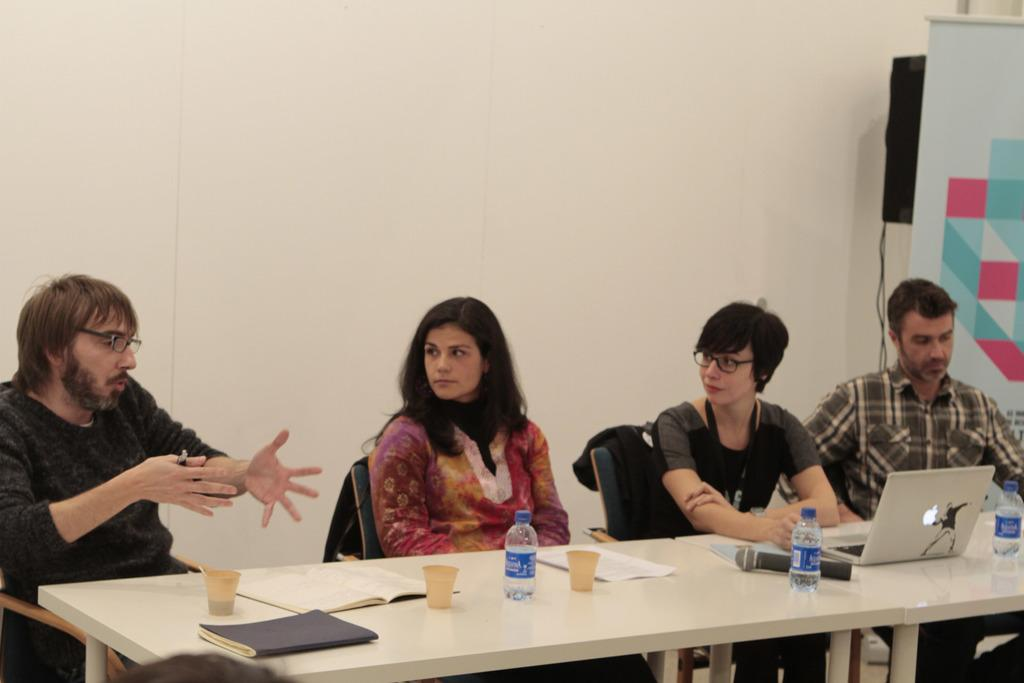How many people are sitting in the image? There are four people sitting on chairs in the image. What objects can be seen on the table in the image? On the table, there is a cup, a book, a water bottle, a mic, and a laptop. What might the people be using the mic for? The people might be using the mic for recording or speaking during a meeting or presentation. What can be used for drinking in the image? The water bottle on the table can be used for drinking. Can you describe the design of the horse in the image? There is no horse present in the image; it features four people sitting on chairs and objects on a table. 